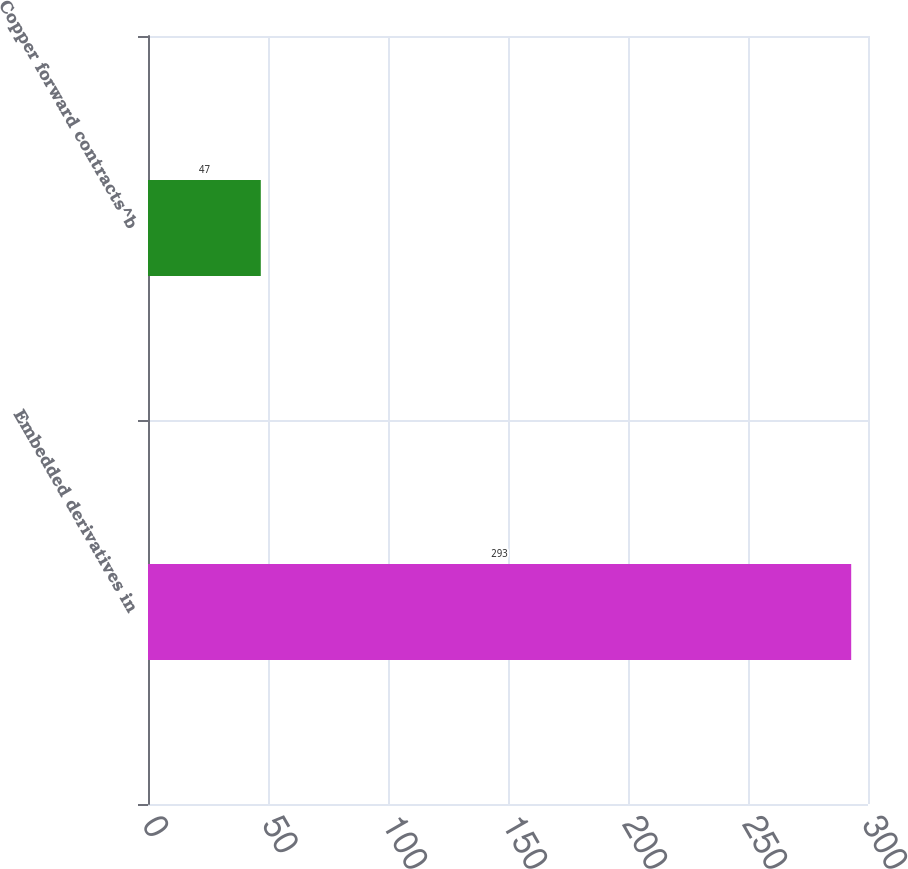<chart> <loc_0><loc_0><loc_500><loc_500><bar_chart><fcel>Embedded derivatives in<fcel>Copper forward contracts^b<nl><fcel>293<fcel>47<nl></chart> 